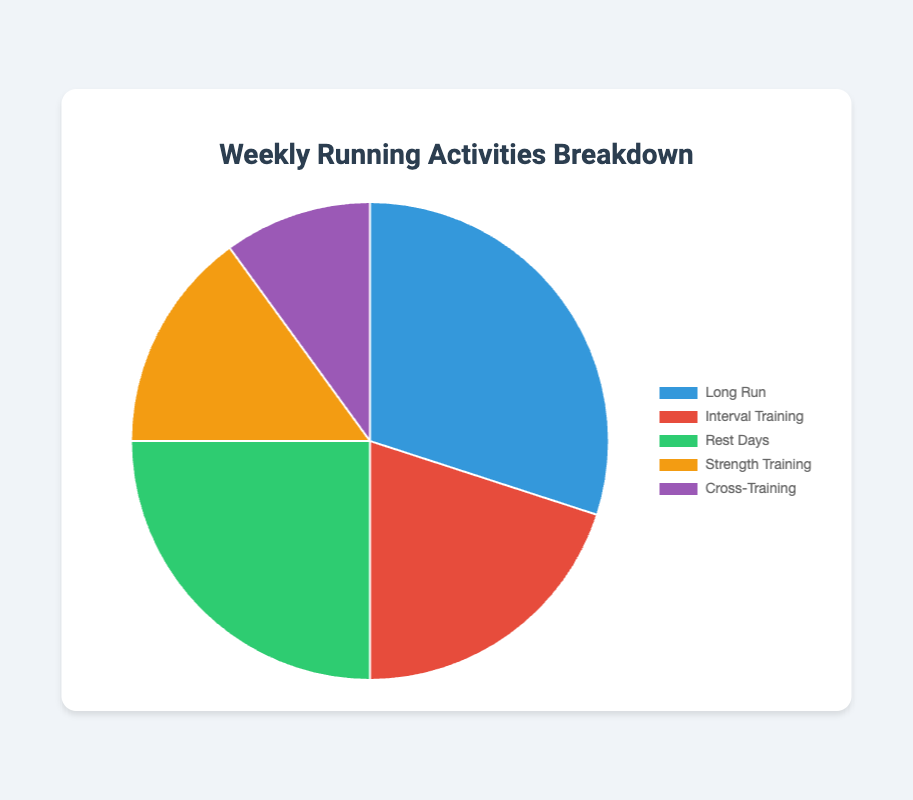What percentage of weekly activities is dedicated to Long Run? The percentage allocated to Long Run is directly stated in the pie chart's legend as 30%.
Answer: 30% How much more time is spent on Interval Training compared to Cross-Training? The pie chart shows Interval Training at 20% and Cross-Training at 10%. The difference is calculated as 20% - 10% = 10%.
Answer: 10% Which activity has the smallest percentage and what is that percentage? From the pie chart, Cross-Training occupies the smallest section with a value of 10%.
Answer: Cross-Training, 10% What is the total percentage spent on Long Run and Rest Days combined? The percentages for Long Run and Rest Days are 30% and 25%, respectively. Adding these together: 30% + 25% = 55%.
Answer: 55% Is the percentage of Rest Days greater than the percentage of Strength Training? The pie chart shows Rest Days at 25% and Strength Training at 15%. Comparing these values indicates that Rest Days (25%) are greater than Strength Training (15%).
Answer: Yes What fraction of the weekly activities is dedicated to Interval Training out of the total time for Interval Training and Cross-Training? Interval Training is 20% and Cross-Training is 10%. The total percentage is 20% + 10% = 30%. The fraction for Interval Training is \( \frac{20}{30} \) or \( \frac{2}{3} \).
Answer: \( \frac{2}{3} \) Which activities have equal or greater percentages compared to Strength Training? Strength Training is at 15%. Activities with equal or greater percentages are Long Run (30%), Interval Training (20%), and Rest Days (25%).
Answer: Long Run, Interval Training, Rest Days What is the average percentage for Interval Training, Rest Days, and Cross-Training? The percentages for Interval Training, Rest Days, and Cross-Training are 20%, 25%, and 10%, respectively. Calculating the average: \( \frac{20 + 25 + 10}{3} = \frac{55}{3} \approx 18.33 \).
Answer: 18.33% If Strength Training and Cross-Training percentages combined matched the percentage of Long Run, what percentage would Cross-Training need to be? Long Run is 30%. Strength Training is currently 15%. To match Long Run, Cross-Training would need to be \( 30% - 15% = 15% \). Since it is currently 10%, an additional 5% is needed.
Answer: 15% 